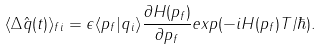Convert formula to latex. <formula><loc_0><loc_0><loc_500><loc_500>\langle \Delta \hat { q } ( t ) \rangle _ { f i } = \epsilon \langle p _ { f } | q _ { i } \rangle \frac { \partial H ( p _ { f } ) } { \partial p _ { f } } e x p ( - i H ( p _ { f } ) T / \hbar { ) } .</formula> 